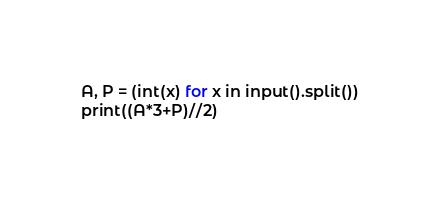Convert code to text. <code><loc_0><loc_0><loc_500><loc_500><_Python_>A, P = (int(x) for x in input().split())
print((A*3+P)//2)</code> 